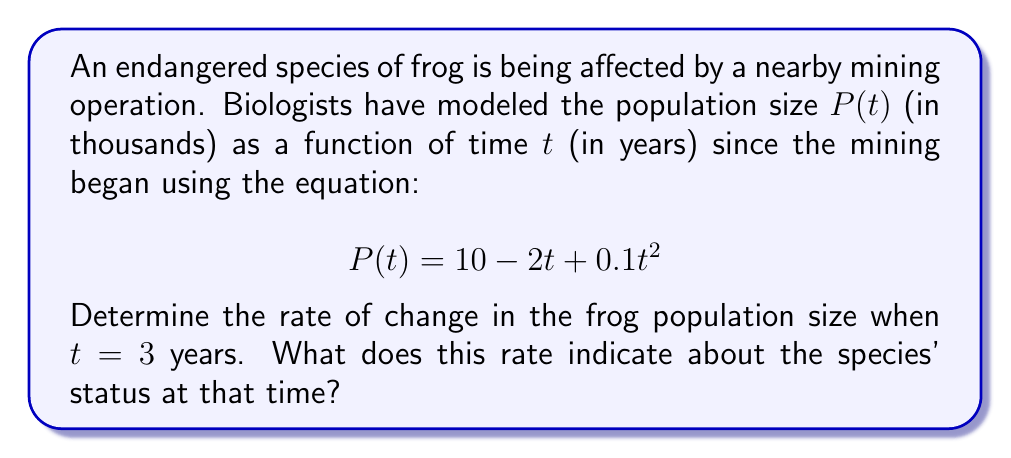What is the answer to this math problem? To solve this problem, we need to find the derivative of the population function and evaluate it at $t = 3$. This will give us the instantaneous rate of change in the population size.

1. First, let's find the derivative of $P(t)$:
   $$P(t) = 10 - 2t + 0.1t^2$$
   $$\frac{dP}{dt} = -2 + 0.2t$$

2. Now, we evaluate the derivative at $t = 3$:
   $$\frac{dP}{dt}\bigg|_{t=3} = -2 + 0.2(3) = -2 + 0.6 = -1.4$$

3. Interpretation:
   The rate of change is -1.4 thousand frogs per year when $t = 3$. The negative value indicates that the population is decreasing at this time.

4. Conservation implications:
   This negative rate of change suggests that the frog species is still declining 3 years after the mining operation began. The population is decreasing at a rate of 1,400 frogs per year at this point, which is concerning for an endangered species. This information could be crucial for conservationists to advocate for more stringent protection measures or changes in mining practices to mitigate the impact on the frog population.
Answer: The rate of change in the frog population size when $t = 3$ years is $-1.4$ thousand frogs per year, indicating that the population is decreasing at that time. 